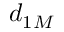<formula> <loc_0><loc_0><loc_500><loc_500>d _ { 1 M }</formula> 